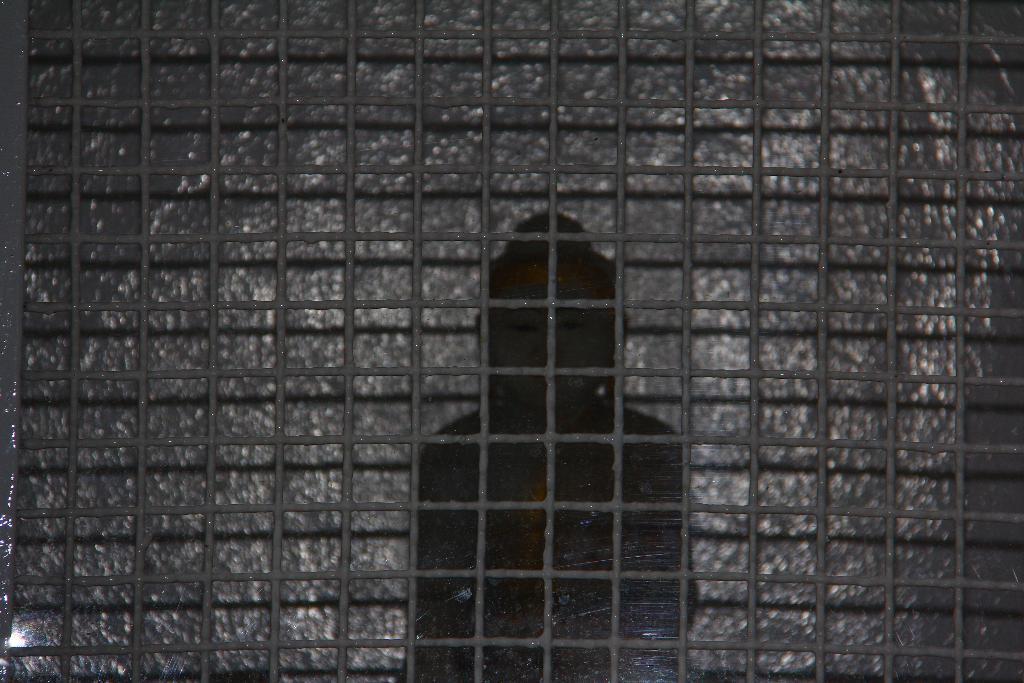Can you describe this image briefly? As we can see in the image there is fence and a wall. 